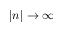Convert formula to latex. <formula><loc_0><loc_0><loc_500><loc_500>| n | \rightarrow \infty</formula> 